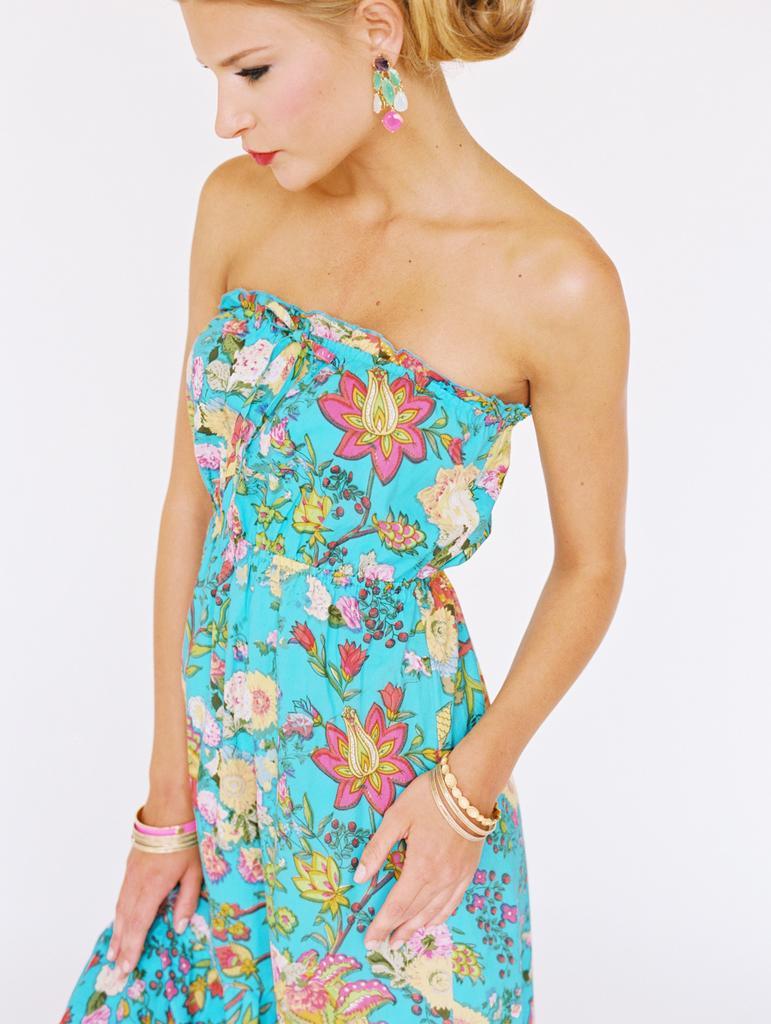Describe this image in one or two sentences. In this picture there is a woman who is wearing earrings, bangles and dress. In the back I can see the brightness. 